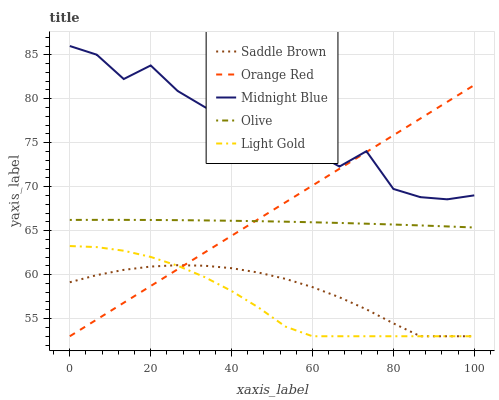Does Light Gold have the minimum area under the curve?
Answer yes or no. Yes. Does Midnight Blue have the maximum area under the curve?
Answer yes or no. Yes. Does Midnight Blue have the minimum area under the curve?
Answer yes or no. No. Does Light Gold have the maximum area under the curve?
Answer yes or no. No. Is Orange Red the smoothest?
Answer yes or no. Yes. Is Midnight Blue the roughest?
Answer yes or no. Yes. Is Light Gold the smoothest?
Answer yes or no. No. Is Light Gold the roughest?
Answer yes or no. No. Does Light Gold have the lowest value?
Answer yes or no. Yes. Does Midnight Blue have the lowest value?
Answer yes or no. No. Does Midnight Blue have the highest value?
Answer yes or no. Yes. Does Light Gold have the highest value?
Answer yes or no. No. Is Light Gold less than Olive?
Answer yes or no. Yes. Is Midnight Blue greater than Saddle Brown?
Answer yes or no. Yes. Does Orange Red intersect Olive?
Answer yes or no. Yes. Is Orange Red less than Olive?
Answer yes or no. No. Is Orange Red greater than Olive?
Answer yes or no. No. Does Light Gold intersect Olive?
Answer yes or no. No. 